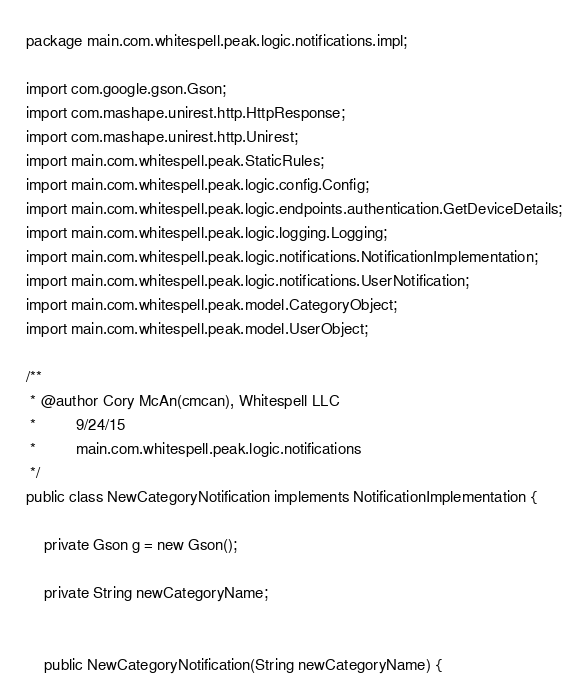<code> <loc_0><loc_0><loc_500><loc_500><_Java_>package main.com.whitespell.peak.logic.notifications.impl;

import com.google.gson.Gson;
import com.mashape.unirest.http.HttpResponse;
import com.mashape.unirest.http.Unirest;
import main.com.whitespell.peak.StaticRules;
import main.com.whitespell.peak.logic.config.Config;
import main.com.whitespell.peak.logic.endpoints.authentication.GetDeviceDetails;
import main.com.whitespell.peak.logic.logging.Logging;
import main.com.whitespell.peak.logic.notifications.NotificationImplementation;
import main.com.whitespell.peak.logic.notifications.UserNotification;
import main.com.whitespell.peak.model.CategoryObject;
import main.com.whitespell.peak.model.UserObject;

/**
 * @author Cory McAn(cmcan), Whitespell LLC
 *         9/24/15
 *         main.com.whitespell.peak.logic.notifications
 */
public class NewCategoryNotification implements NotificationImplementation {

    private Gson g = new Gson();

    private String newCategoryName;


    public NewCategoryNotification(String newCategoryName) {</code> 